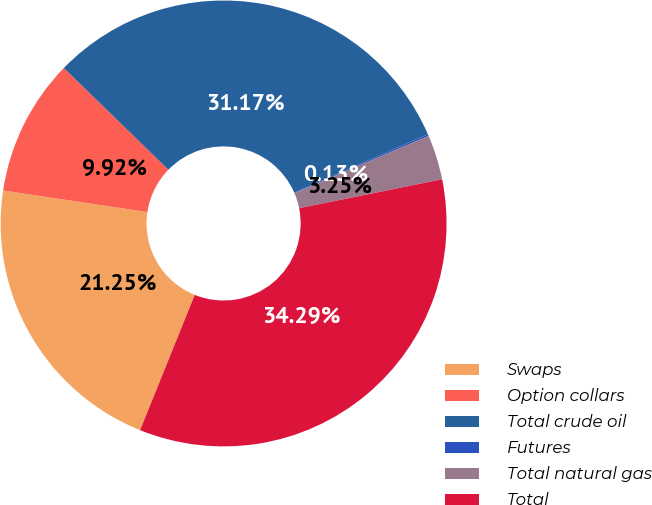<chart> <loc_0><loc_0><loc_500><loc_500><pie_chart><fcel>Swaps<fcel>Option collars<fcel>Total crude oil<fcel>Futures<fcel>Total natural gas<fcel>Total<nl><fcel>21.25%<fcel>9.92%<fcel>31.17%<fcel>0.13%<fcel>3.25%<fcel>34.29%<nl></chart> 